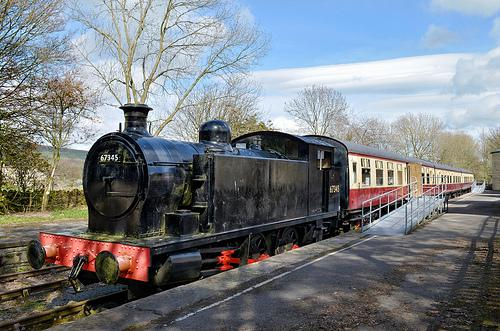Question: what is the train on?
Choices:
A. Track.
B. The ground.
C. The hill.
D. The mountain.
Answer with the letter. Answer: A 